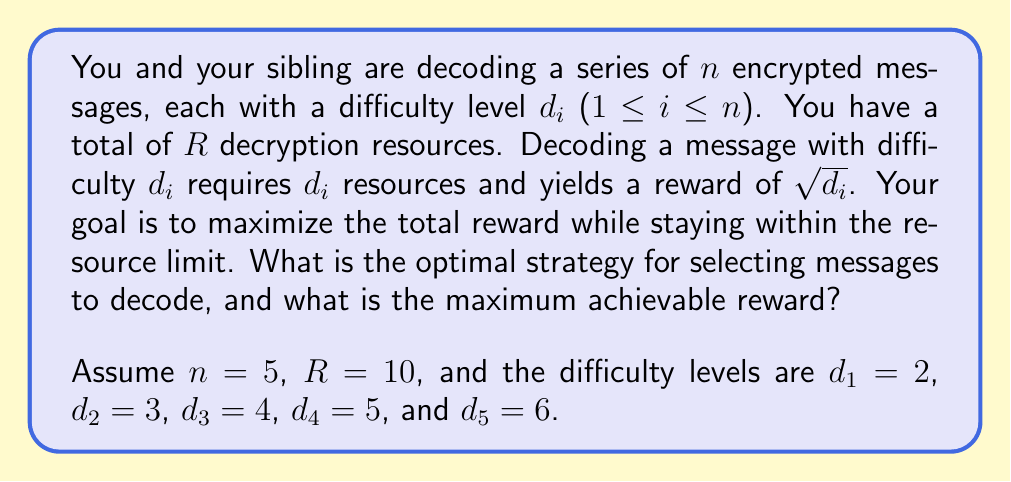Give your solution to this math problem. To solve this problem, we can use the concept of the knapsack problem from game theory. Here's a step-by-step approach:

1) First, calculate the reward-to-resource ratio for each message:
   $\frac{\text{reward}}{\text{resource}} = \frac{\sqrt{d_i}}{d_i} = \frac{1}{\sqrt{d_i}}$

2) For the given difficulties:
   Message 1: $\frac{1}{\sqrt{2}} \approx 0.7071$
   Message 2: $\frac{1}{\sqrt{3}} \approx 0.5774$
   Message 3: $\frac{1}{\sqrt{4}} = 0.5000$
   Message 4: $\frac{1}{\sqrt{5}} \approx 0.4472$
   Message 5: $\frac{1}{\sqrt{6}} \approx 0.4082$

3) The optimal strategy is to select messages in descending order of their reward-to-resource ratio until the resource limit is reached.

4) Following this strategy:
   Select Message 1 (2 resources used, 8 remaining)
   Select Message 2 (5 resources used, 5 remaining)
   Select Message 3 (9 resources used, 1 remaining)

5) We can't select Message 4 or 5 as they require more resources than we have left.

6) Calculate the total reward:
   $\sqrt{2} + \sqrt{3} + \sqrt{4} = \sqrt{2} + \sqrt{3} + 2 \approx 5.1462$

Therefore, the optimal strategy is to decode messages 1, 2, and 3 in that order, yielding a maximum reward of approximately 5.1462.
Answer: The optimal strategy is to decode messages in descending order of their reward-to-resource ratio: Message 1, Message 2, and Message 3. The maximum achievable reward is $\sqrt{2} + \sqrt{3} + 2 \approx 5.1462$. 